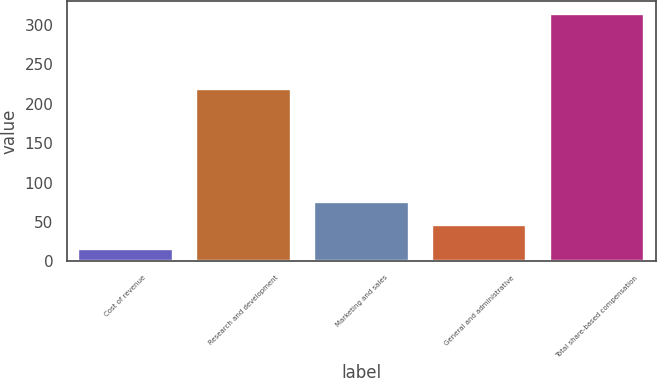Convert chart to OTSL. <chart><loc_0><loc_0><loc_500><loc_500><bar_chart><fcel>Cost of revenue<fcel>Research and development<fcel>Marketing and sales<fcel>General and administrative<fcel>Total share-based compensation<nl><fcel>16<fcel>219<fcel>75.6<fcel>45.8<fcel>314<nl></chart> 